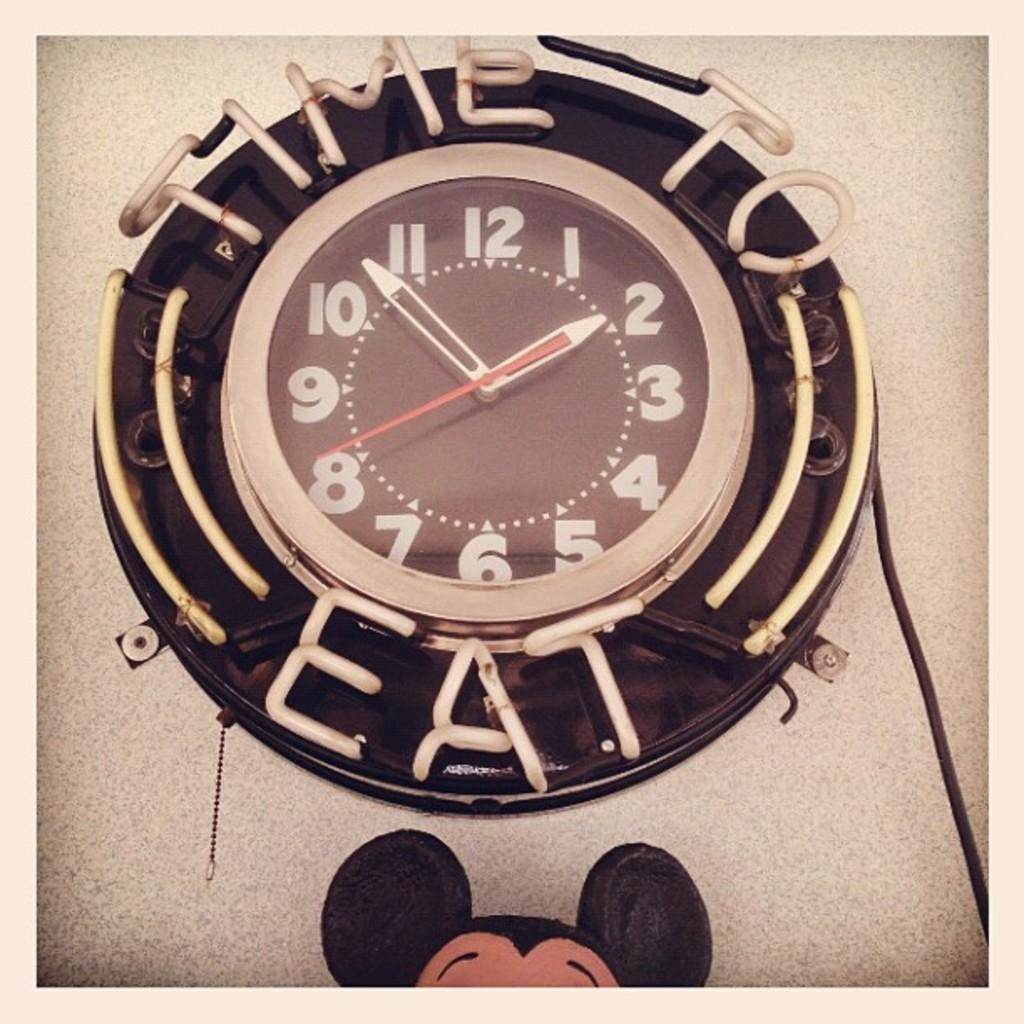<image>
Create a compact narrative representing the image presented. A sign around a clock says that it is time to eat. 